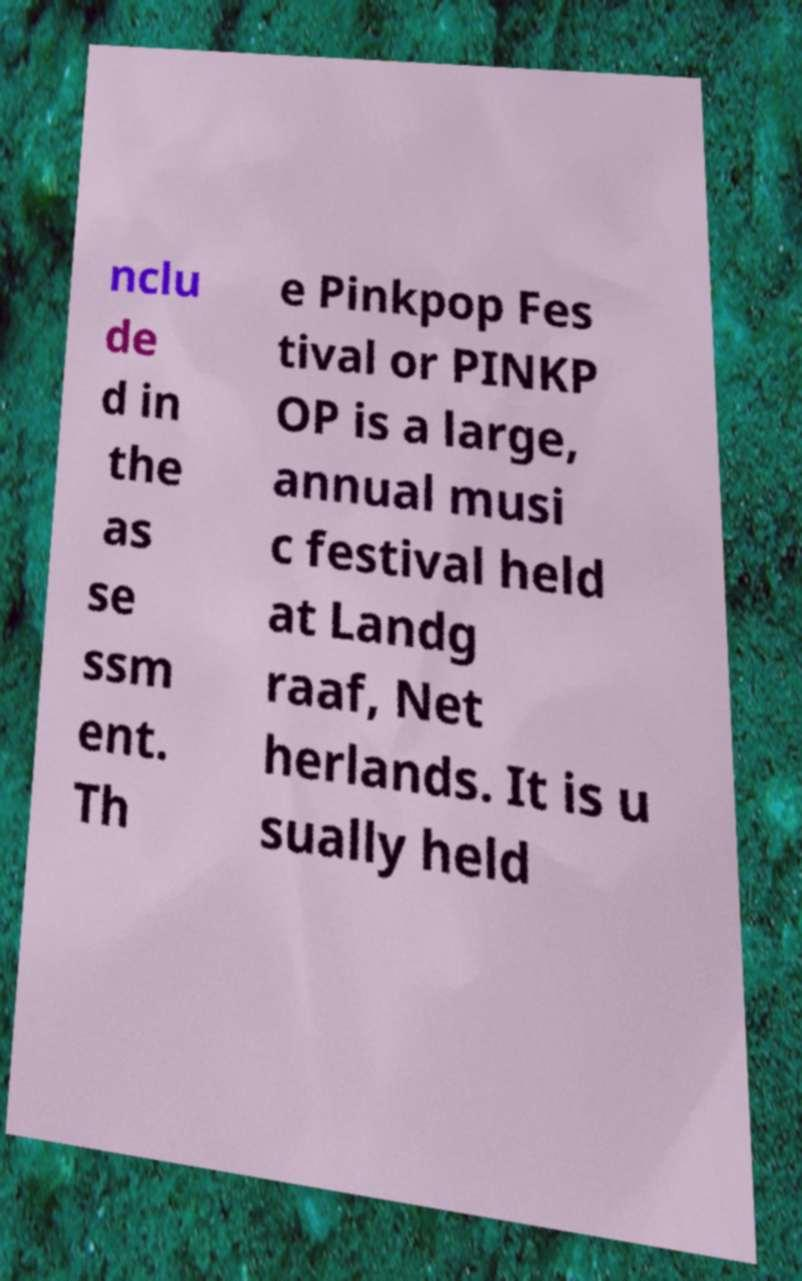Could you assist in decoding the text presented in this image and type it out clearly? nclu de d in the as se ssm ent. Th e Pinkpop Fes tival or PINKP OP is a large, annual musi c festival held at Landg raaf, Net herlands. It is u sually held 